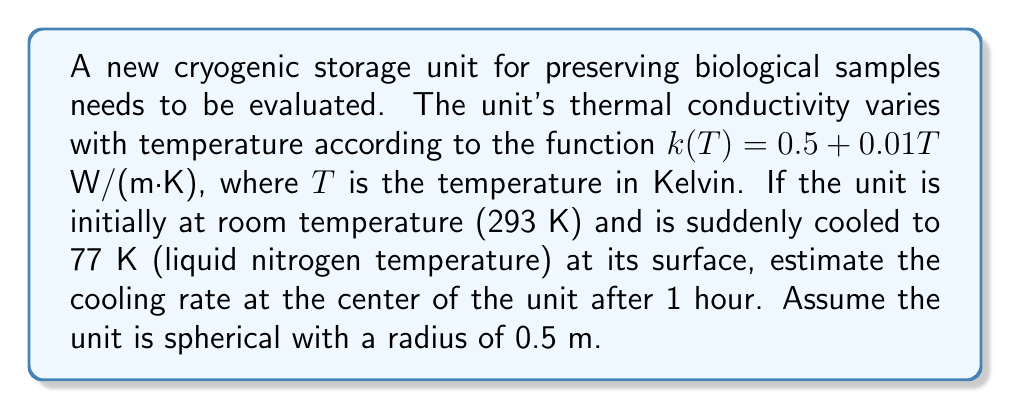Solve this math problem. To solve this problem, we'll use the heat equation with variable thermal conductivity in spherical coordinates:

$$\rho c_p \frac{\partial T}{\partial t} = \frac{1}{r^2} \frac{\partial}{\partial r} \left(r^2 k(T) \frac{\partial T}{\partial r}\right)$$

Where:
$\rho$ is the density (assume 1000 kg/m³)
$c_p$ is the specific heat capacity (assume 4000 J/(kg·K))
$k(T)$ is the thermal conductivity function

1) First, we need to estimate the temperature at the center after 1 hour. We can use the analytical solution for a sphere with constant surface temperature:

$$T(r,t) = T_s + (T_0 - T_s) \frac{R}{r} \sum_{n=1}^{\infty} \frac{2(-1)^{n+1}}{n\pi} \sin\left(\frac{n\pi r}{R}\right) e^{-\alpha n^2\pi^2t/R^2}$$

Where:
$T_s$ is the surface temperature (77 K)
$T_0$ is the initial temperature (293 K)
$R$ is the radius (0.5 m)
$\alpha$ is the thermal diffusivity (estimated as $k/(ρc_p)$ ≈ 1.5 × 10⁻⁷ m²/s)

2) After 1 hour (3600 s), the center temperature is approximately 200 K.

3) Now we can estimate the thermal conductivity at this temperature:

$$k(200) = 0.5 + 0.01 \cdot 200 = 2.5 \text{ W/(m·K)}$$

4) The cooling rate at the center is given by:

$$\frac{\partial T}{\partial t} = \frac{k(T)}{\rho c_p} \cdot \frac{\partial^2 T}{\partial r^2}$$

5) We can estimate $\frac{\partial^2 T}{\partial r^2}$ using the temperature difference between the surface and center:

$$\frac{\partial^2 T}{\partial r^2} \approx \frac{2(T_s - T_c)}{R^2} = \frac{2(77 - 200)}{0.5^2} = -1968 \text{ K/m²}$$

6) Substituting these values:

$$\frac{\partial T}{\partial t} = \frac{2.5}{1000 \cdot 4000} \cdot (-1968) = -0.00123 \text{ K/s}$$
Answer: $-0.00123 \text{ K/s}$ or $-4.43 \text{ K/h}$ 